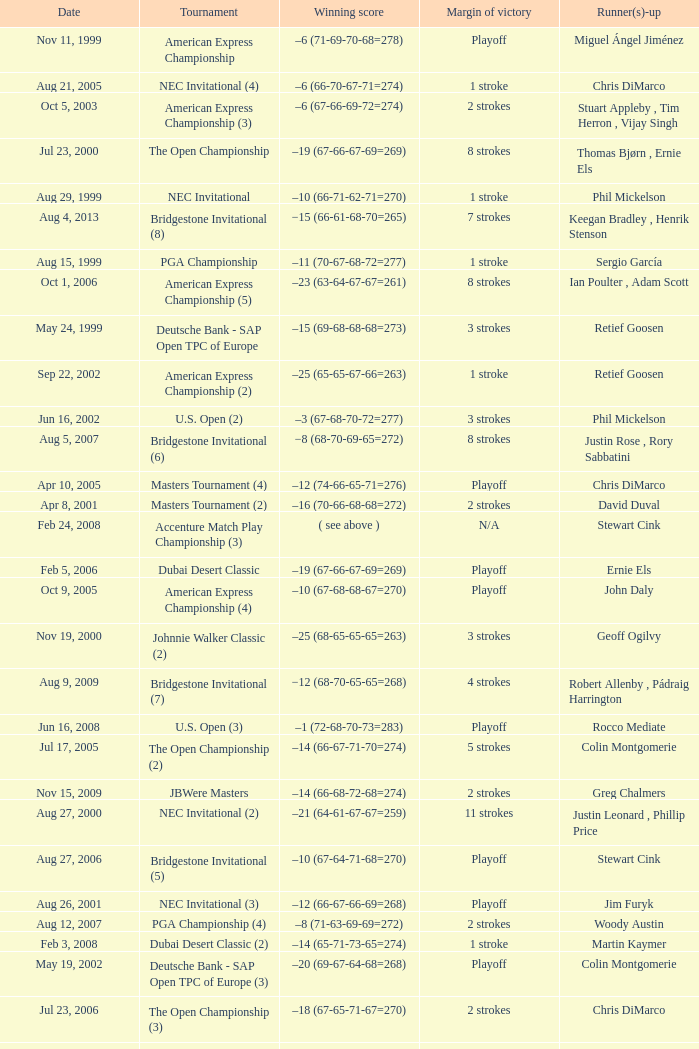Who is Runner(s)-up that has a Date of may 24, 1999? Retief Goosen. 